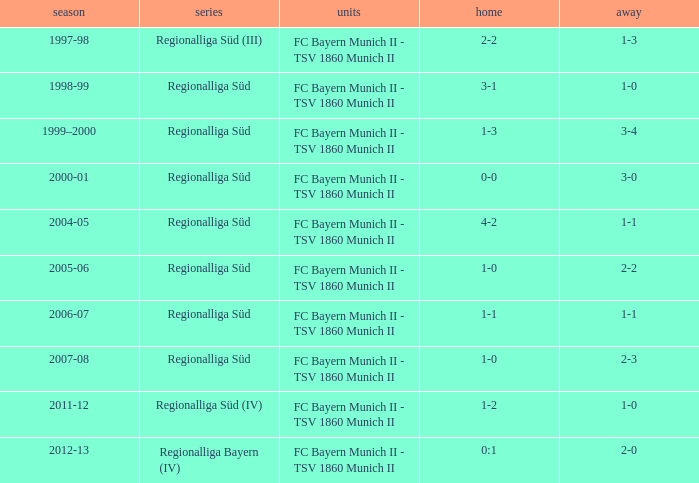What league has a 3-1 home? Regionalliga Süd. 